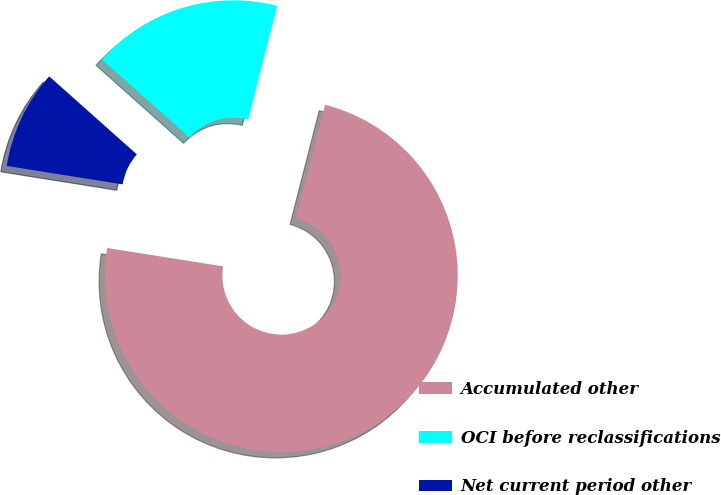<chart> <loc_0><loc_0><loc_500><loc_500><pie_chart><fcel>Accumulated other<fcel>OCI before reclassifications<fcel>Net current period other<nl><fcel>73.52%<fcel>17.41%<fcel>9.07%<nl></chart> 